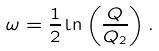<formula> <loc_0><loc_0><loc_500><loc_500>\omega = \frac { 1 } { 2 } \ln \left ( \frac { Q } { Q _ { 2 } } \right ) .</formula> 